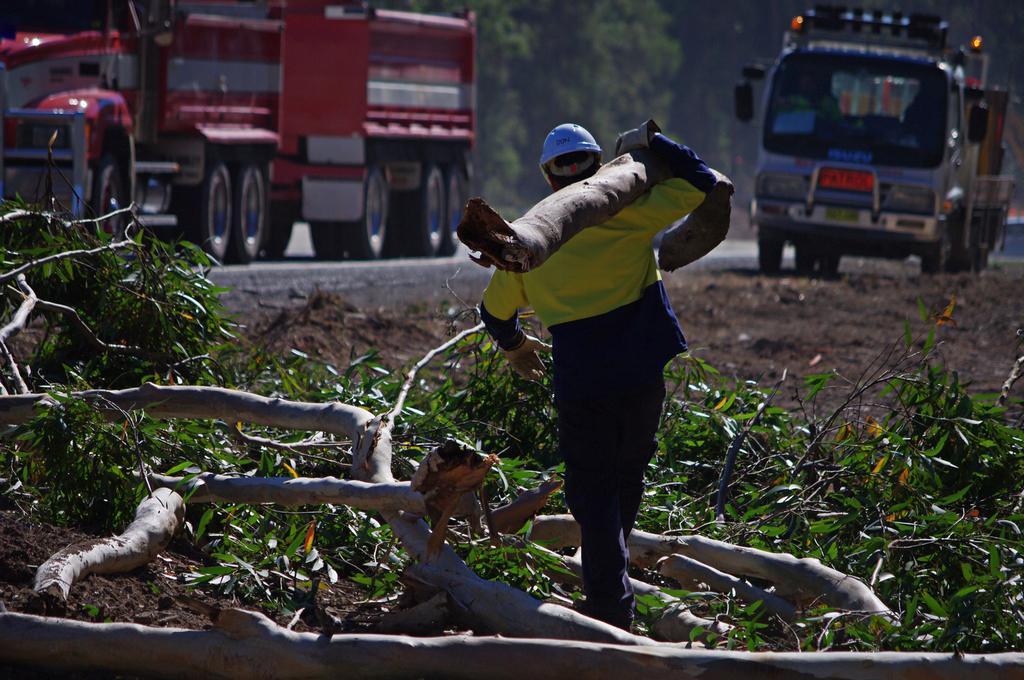In one or two sentences, can you explain what this image depicts? In this picture we can see trees, vehicles. We can see a man wearing a helmet and he is carrying a branch on his shoulder. We can see branches and leaves. 